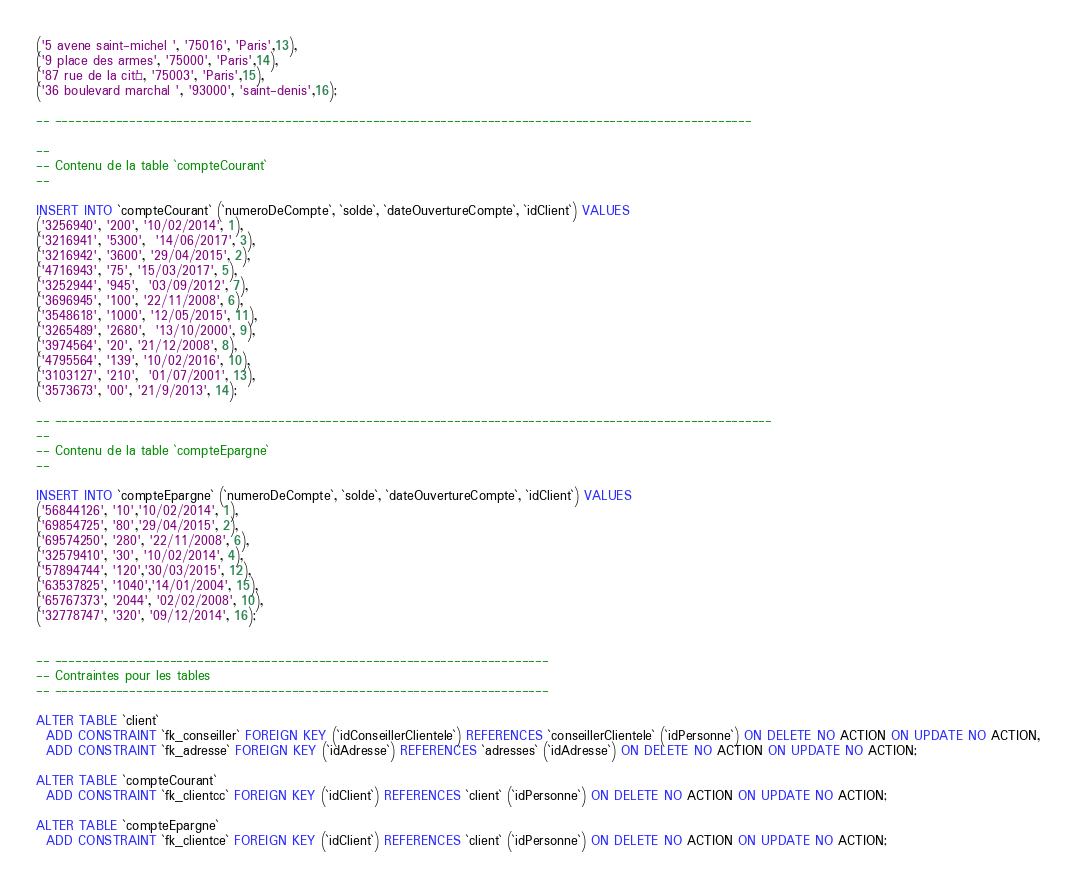<code> <loc_0><loc_0><loc_500><loc_500><_SQL_>('5 avene saint-michel ', '75016', 'Paris',13),
('9 place des armes', '75000', 'Paris',14),
('87 rue de la cité', '75003', 'Paris',15),
('36 boulevard marchal ', '93000', 'saint-denis',16);

-- -------------------------------------------------------------------------------------------------------

--
-- Contenu de la table `compteCourant`
--

INSERT INTO `compteCourant` (`numeroDeCompte`, `solde`, `dateOuvertureCompte`, `idClient`) VALUES
('3256940', '200', '10/02/2014', 1),
('3216941', '5300',  '14/06/2017', 3),
('3216942', '3600', '29/04/2015', 2),
('4716943', '75', '15/03/2017', 5),
('3252944', '945',  '03/09/2012', 7),
('3696945', '100', '22/11/2008', 6),
('3548618', '1000', '12/05/2015', 11),
('3265489', '2680',  '13/10/2000', 9),
('3974564', '20', '21/12/2008', 8),
('4795564', '139', '10/02/2016', 10),
('3103127', '210',  '01/07/2001', 13),
('3573673', '00', '21/9/2013', 14);

-- ----------------------------------------------------------------------------------------------------------
--
-- Contenu de la table `compteEpargne`
--

INSERT INTO `compteEpargne` (`numeroDeCompte`, `solde`, `dateOuvertureCompte`, `idClient`) VALUES
('56844126', '10','10/02/2014', 1),
('69854725', '80','29/04/2015', 2),
('69574250', '280', '22/11/2008', 6),
('32579410', '30', '10/02/2014', 4),
('57894744', '120','30/03/2015', 12),
('63537825', '1040','14/01/2004', 15),
('65767373', '2044', '02/02/2008', 10),
('32778747', '320', '09/12/2014', 16);


-- -------------------------------------------------------------------------
-- Contraintes pour les tables
-- -------------------------------------------------------------------------

ALTER TABLE `client`
  ADD CONSTRAINT `fk_conseiller` FOREIGN KEY (`idConseillerClientele`) REFERENCES `conseillerClientele` (`idPersonne`) ON DELETE NO ACTION ON UPDATE NO ACTION,
  ADD CONSTRAINT `fk_adresse` FOREIGN KEY (`idAdresse`) REFERENCES `adresses` (`idAdresse`) ON DELETE NO ACTION ON UPDATE NO ACTION;

ALTER TABLE `compteCourant`
  ADD CONSTRAINT `fk_clientcc` FOREIGN KEY (`idClient`) REFERENCES `client` (`idPersonne`) ON DELETE NO ACTION ON UPDATE NO ACTION;

ALTER TABLE `compteEpargne`
  ADD CONSTRAINT `fk_clientce` FOREIGN KEY (`idClient`) REFERENCES `client` (`idPersonne`) ON DELETE NO ACTION ON UPDATE NO ACTION;</code> 